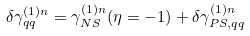<formula> <loc_0><loc_0><loc_500><loc_500>\delta \gamma _ { q q } ^ { ( 1 ) n } = \gamma _ { N S } ^ { ( 1 ) n } ( \eta = - 1 ) + \delta \gamma _ { P S , q q } ^ { ( 1 ) n }</formula> 